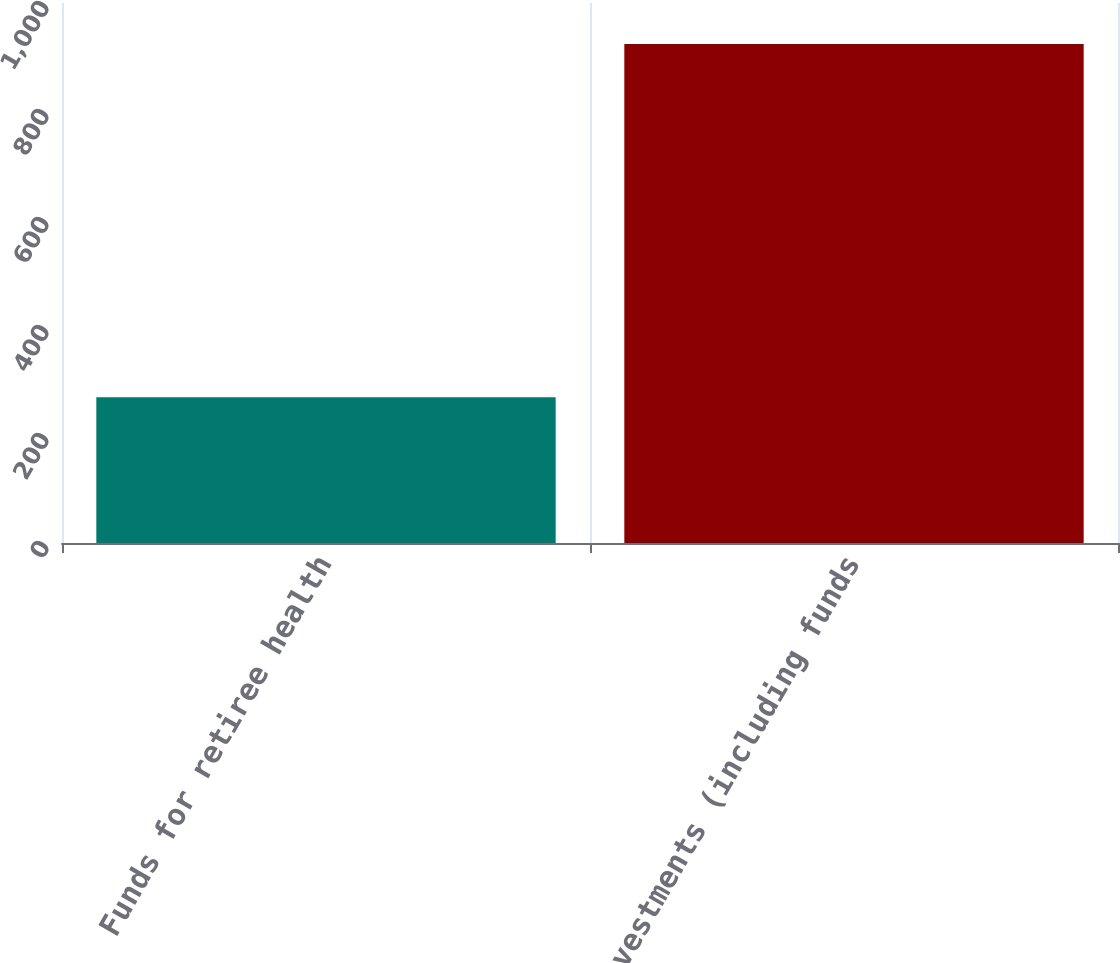Convert chart to OTSL. <chart><loc_0><loc_0><loc_500><loc_500><bar_chart><fcel>Funds for retiree health<fcel>Investments (including funds<nl><fcel>270<fcel>924<nl></chart> 